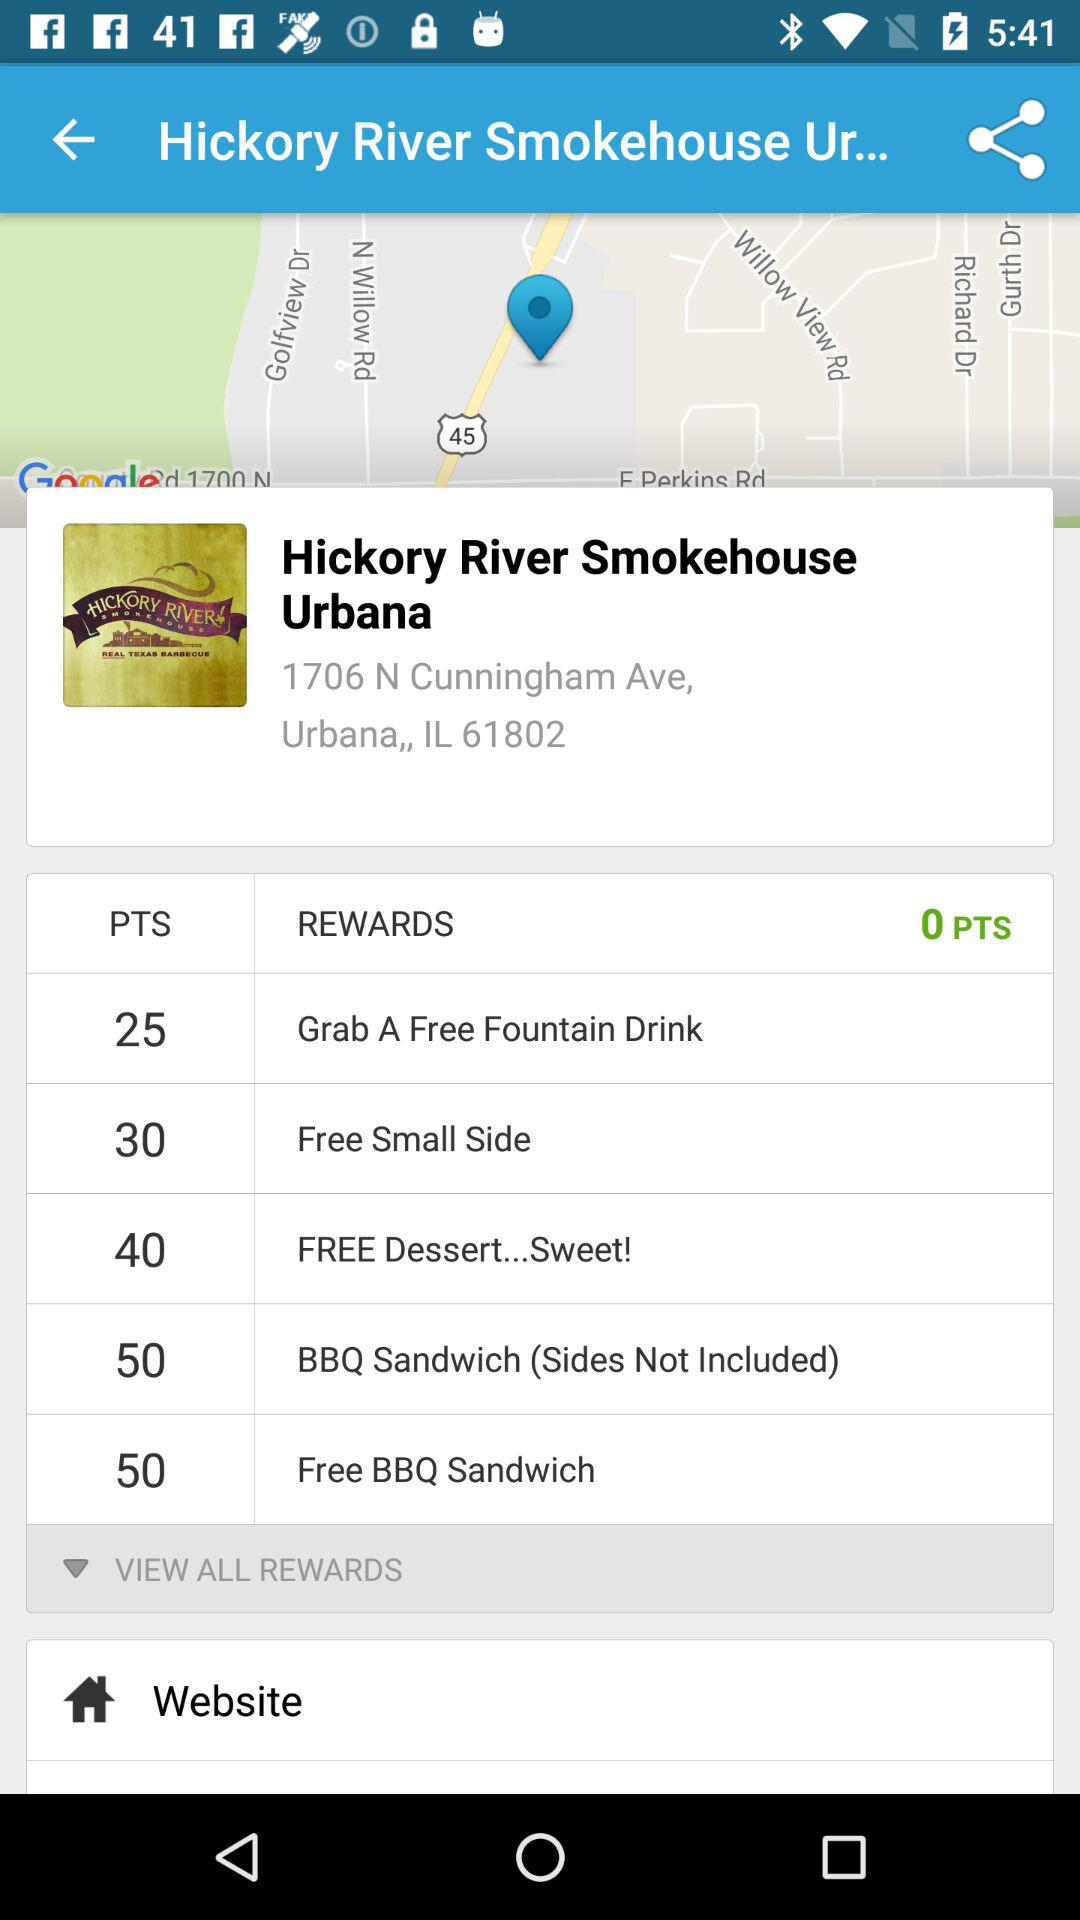How many PTS are there in the balance? There are 0 PTS in the balance. 